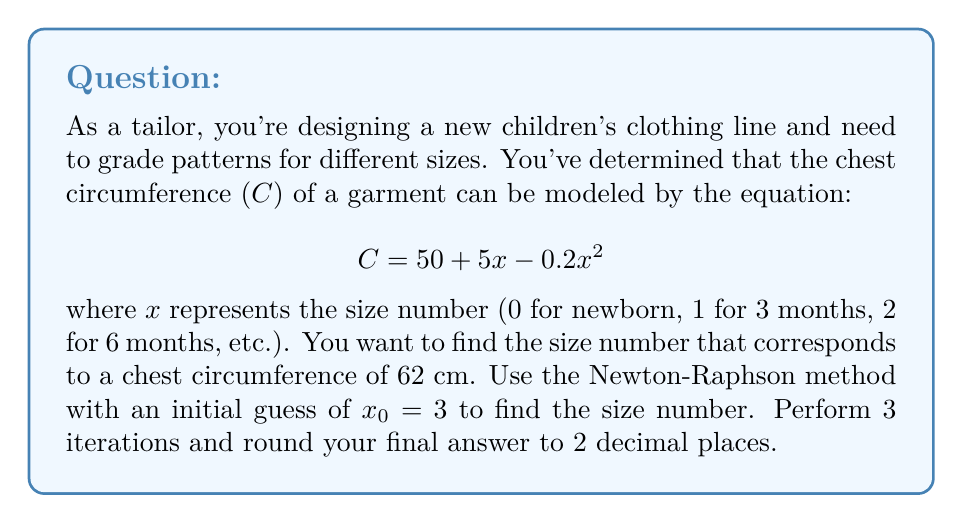Can you solve this math problem? To solve this problem using the Newton-Raphson method, we follow these steps:

1) First, we rewrite the equation to find the root:
   $$f(x) = 50 + 5x - 0.2x^2 - 62 = 0$$
   $$f(x) = -0.2x^2 + 5x - 12 = 0$$

2) We need to find the derivative of $f(x)$:
   $$f'(x) = -0.4x + 5$$

3) The Newton-Raphson formula is:
   $$x_{n+1} = x_n - \frac{f(x_n)}{f'(x_n)}$$

4) Now, let's perform 3 iterations:

   Iteration 1:
   $$f(3) = -0.2(3)^2 + 5(3) - 12 = -1.8 - 12 = -1.8$$
   $$f'(3) = -0.4(3) + 5 = 3.8$$
   $$x_1 = 3 - \frac{-1.8}{3.8} = 3.4737$$

   Iteration 2:
   $$f(3.4737) = -0.2(3.4737)^2 + 5(3.4737) - 12 = -0.1063$$
   $$f'(3.4737) = -0.4(3.4737) + 5 = 3.6105$$
   $$x_2 = 3.4737 - \frac{-0.1063}{3.6105} = 3.5031$$

   Iteration 3:
   $$f(3.5031) = -0.2(3.5031)^2 + 5(3.5031) - 12 = -0.0004$$
   $$f'(3.5031) = -0.4(3.5031) + 5 = 3.5988$$
   $$x_3 = 3.5031 - \frac{-0.0004}{3.5988} = 3.5032$$

5) Rounding to 2 decimal places, we get 3.50.
Answer: $3.50$ 